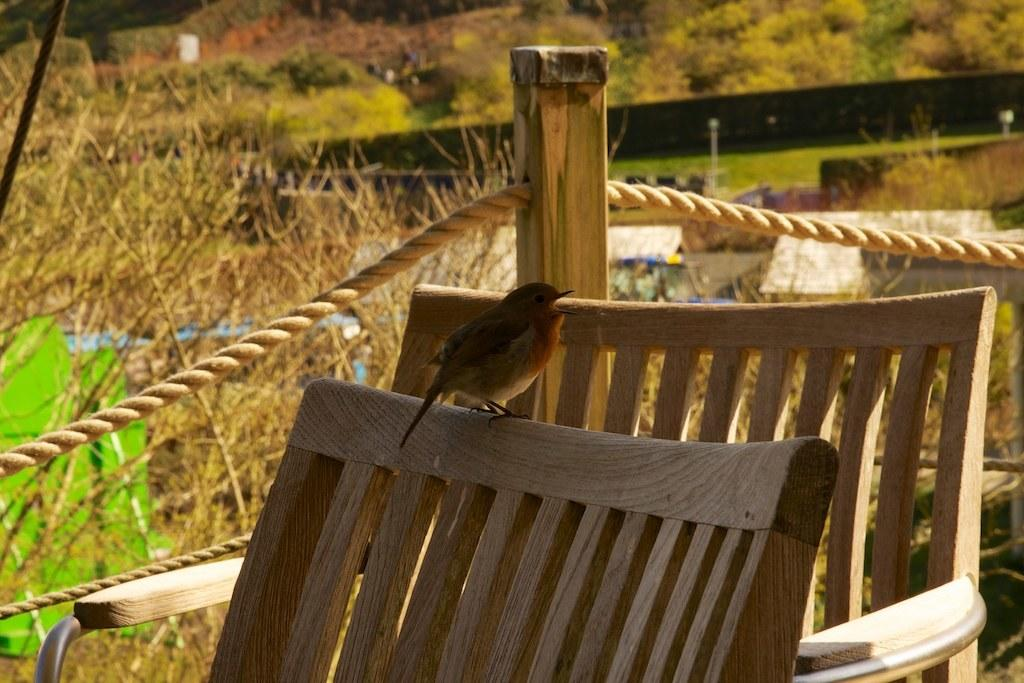What type of furniture is in the image? There is a chair in the image. What is located above the chair? A bird is present above the chair. What type of natural environment is visible in the background of the image? There are trees visible in the background of the image. What objects can be seen in the background of the image? There is a wooden stick and a rope in the background of the image. What type of act is the chair performing in the image? Chairs do not perform acts; they are inanimate objects. Is there a birthday celebration happening in the image? There is no indication of a birthday celebration in the image. 